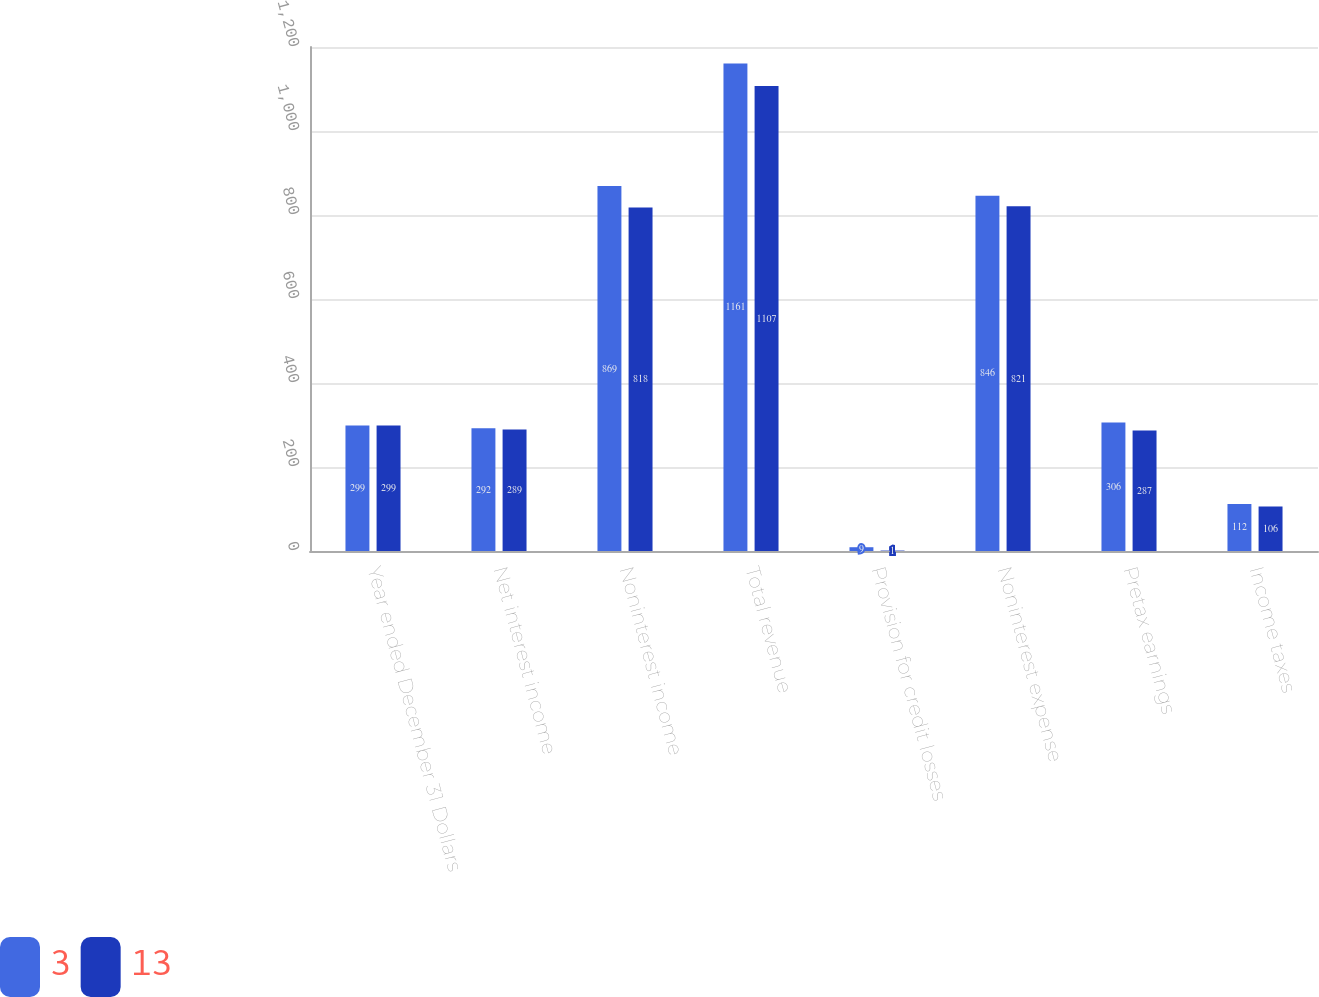Convert chart to OTSL. <chart><loc_0><loc_0><loc_500><loc_500><stacked_bar_chart><ecel><fcel>Year ended December 31 Dollars<fcel>Net interest income<fcel>Noninterest income<fcel>Total revenue<fcel>Provision for credit losses<fcel>Noninterest expense<fcel>Pretax earnings<fcel>Income taxes<nl><fcel>3<fcel>299<fcel>292<fcel>869<fcel>1161<fcel>9<fcel>846<fcel>306<fcel>112<nl><fcel>13<fcel>299<fcel>289<fcel>818<fcel>1107<fcel>1<fcel>821<fcel>287<fcel>106<nl></chart> 